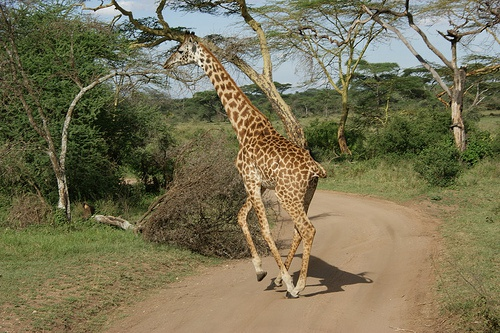Describe the objects in this image and their specific colors. I can see a giraffe in gray, tan, maroon, and olive tones in this image. 